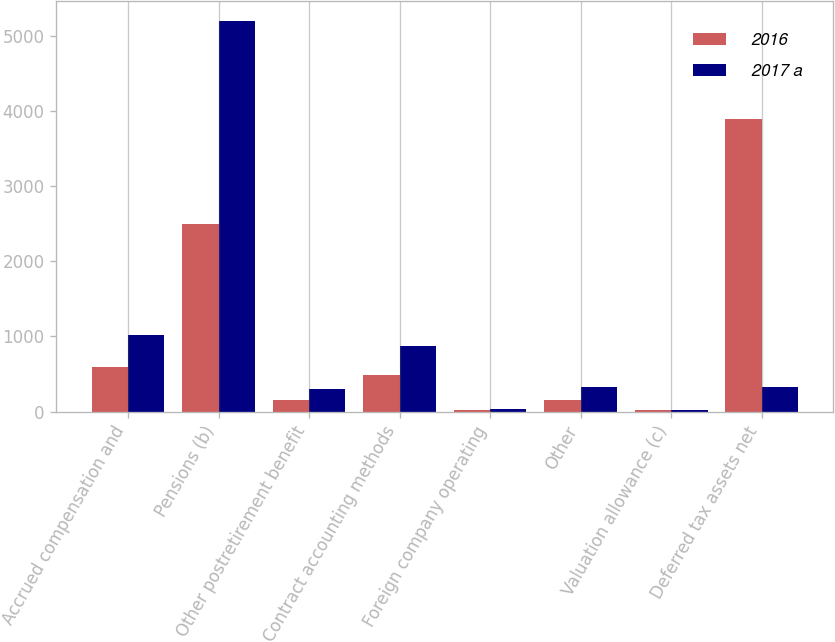Convert chart to OTSL. <chart><loc_0><loc_0><loc_500><loc_500><stacked_bar_chart><ecel><fcel>Accrued compensation and<fcel>Pensions (b)<fcel>Other postretirement benefit<fcel>Contract accounting methods<fcel>Foreign company operating<fcel>Other<fcel>Valuation allowance (c)<fcel>Deferred tax assets net<nl><fcel>2016<fcel>595<fcel>2495<fcel>153<fcel>487<fcel>27<fcel>154<fcel>20<fcel>3891<nl><fcel>2017 a<fcel>1012<fcel>5197<fcel>302<fcel>878<fcel>30<fcel>327<fcel>15<fcel>327<nl></chart> 